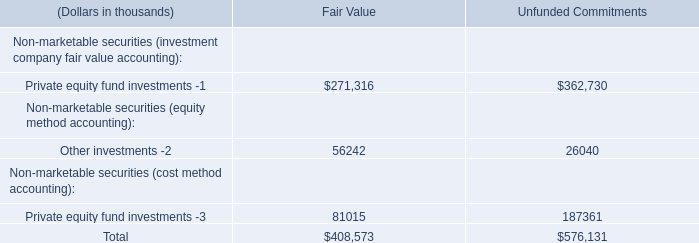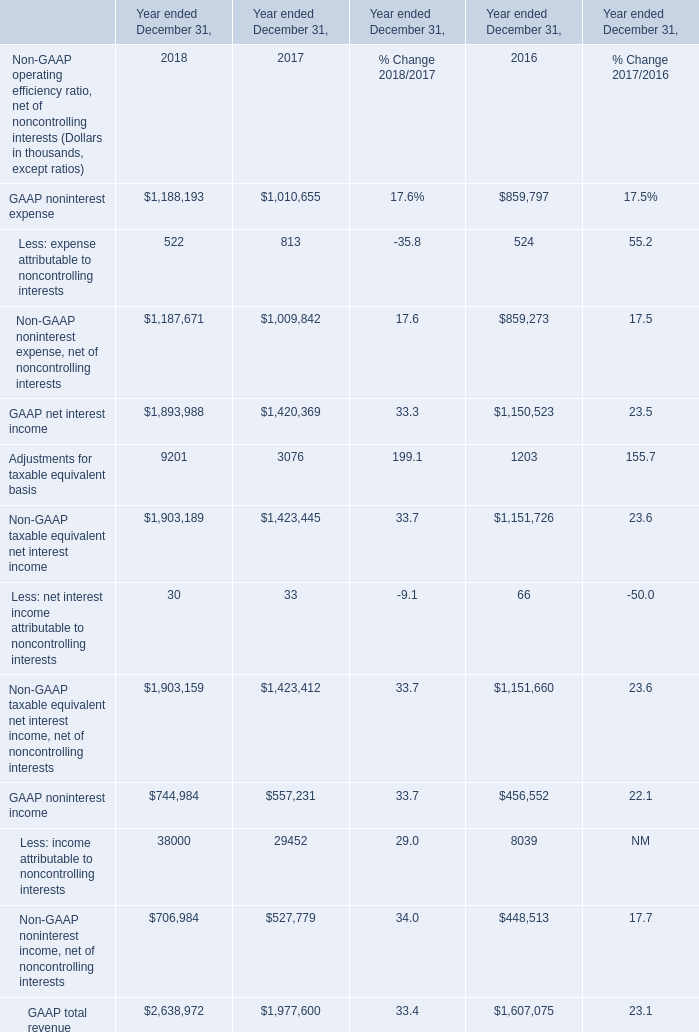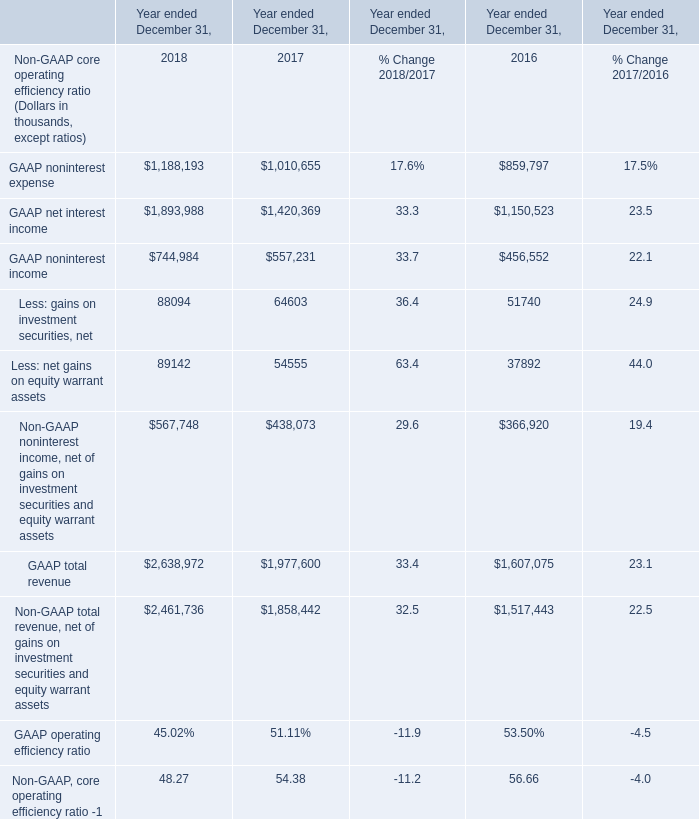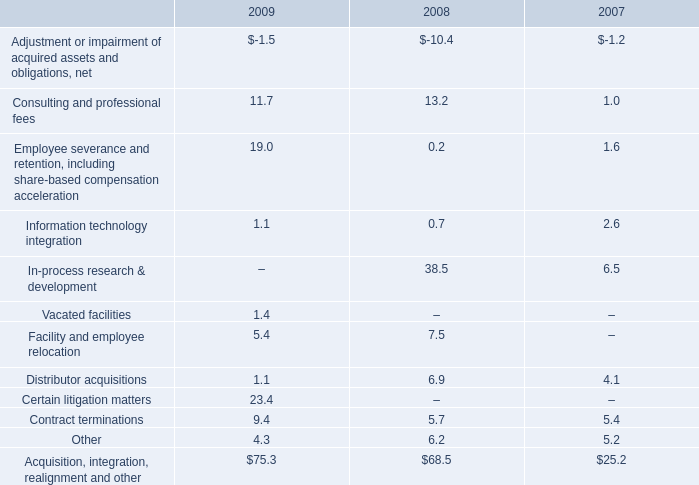Does Less: net interest income attributable to noncontrolling interests keeps increasing each year between 2016 and 2017 
Answer: no. 